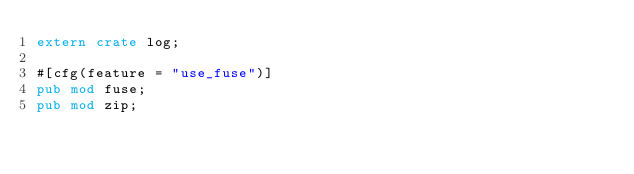<code> <loc_0><loc_0><loc_500><loc_500><_Rust_>extern crate log;

#[cfg(feature = "use_fuse")]
pub mod fuse;
pub mod zip;
</code> 